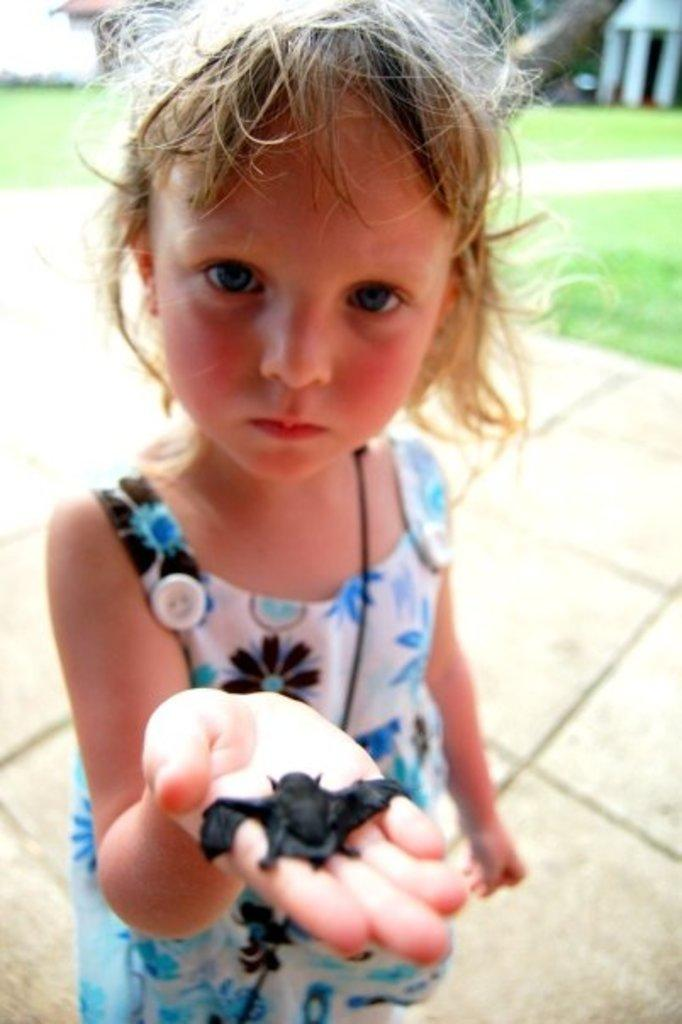Who is the main subject in the image? There is a girl in the image. What is the girl doing in the image? The girl is standing on the floor and holding a bat in her hand. What can be seen in the background of the image? There is grass, trees, and a building in the background of the image. When was the image taken? The image was taken during the day. What type of scissors is the girl using to cut the trees in the background? There are no scissors present in the image, and the girl is not cutting any trees. 